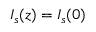<formula> <loc_0><loc_0><loc_500><loc_500>I _ { s } ( z ) = I _ { s } ( 0 )</formula> 